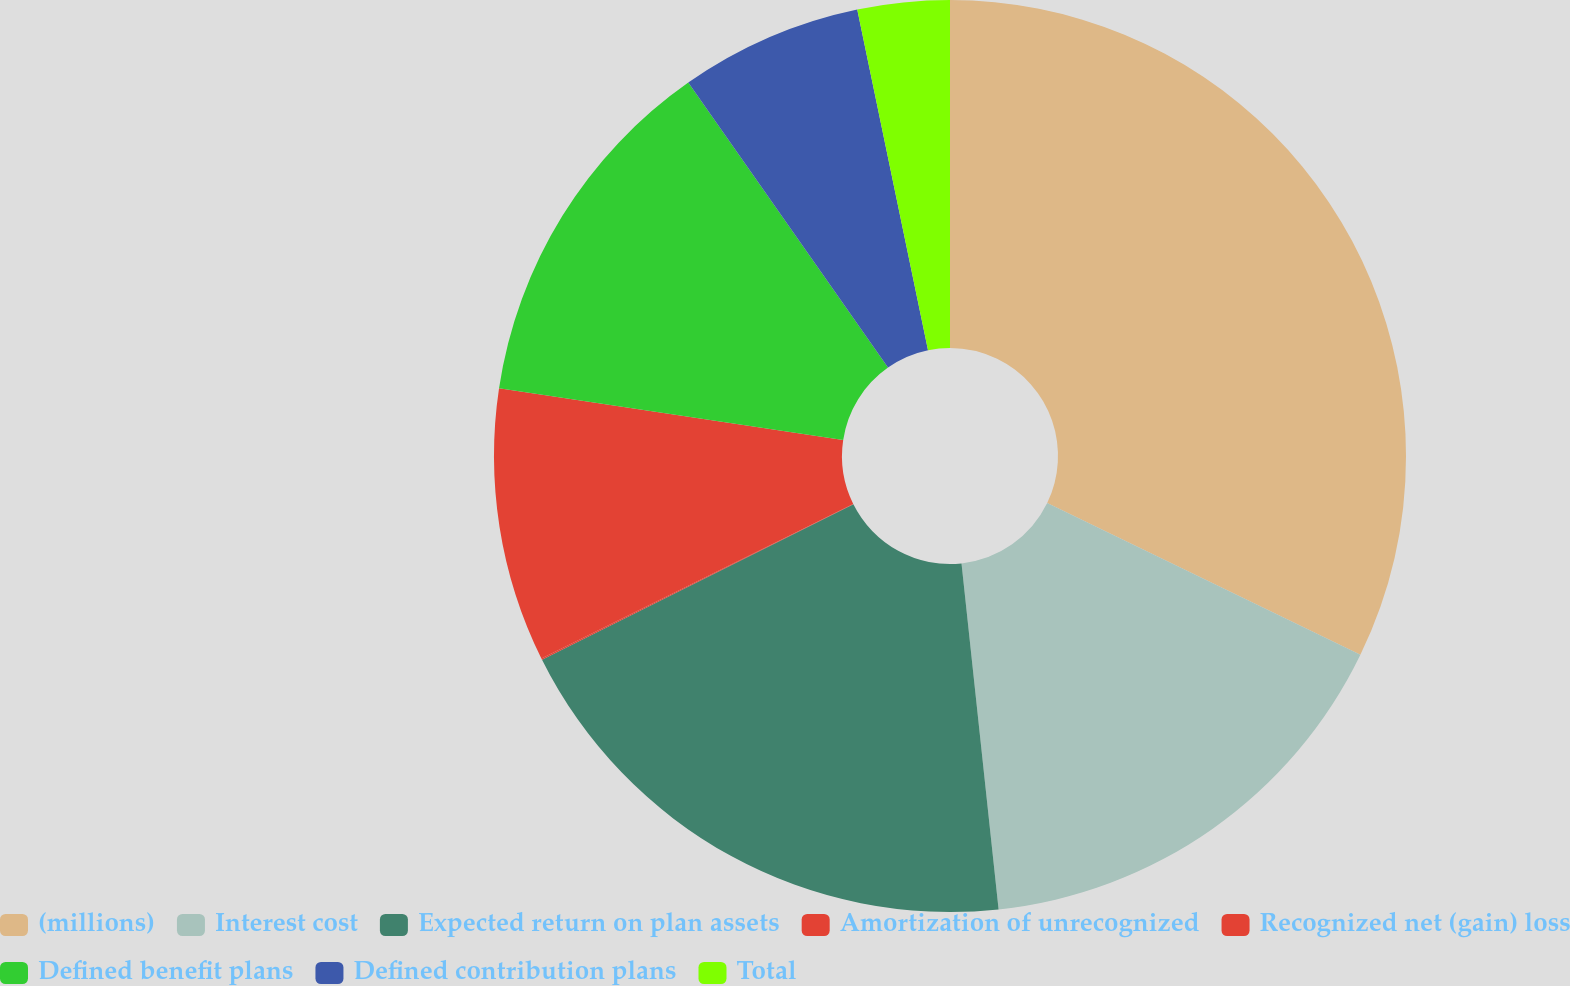<chart> <loc_0><loc_0><loc_500><loc_500><pie_chart><fcel>(millions)<fcel>Interest cost<fcel>Expected return on plan assets<fcel>Amortization of unrecognized<fcel>Recognized net (gain) loss<fcel>Defined benefit plans<fcel>Defined contribution plans<fcel>Total<nl><fcel>32.18%<fcel>16.12%<fcel>19.33%<fcel>0.05%<fcel>9.69%<fcel>12.9%<fcel>6.47%<fcel>3.26%<nl></chart> 